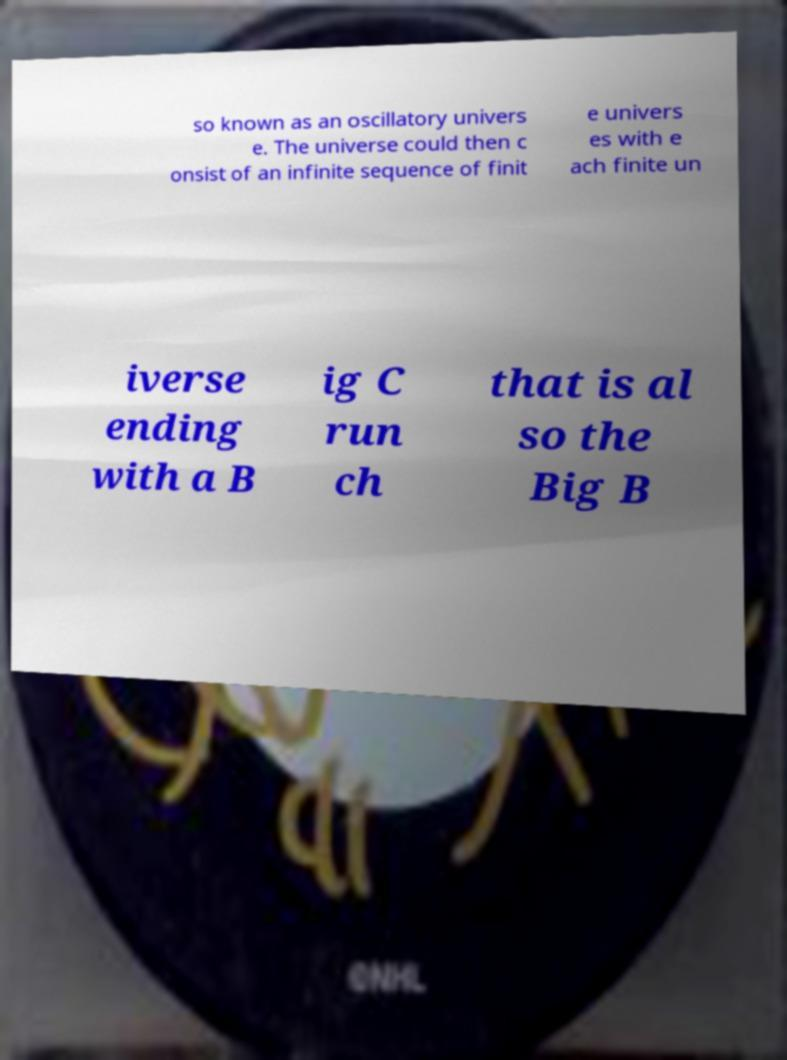Please identify and transcribe the text found in this image. so known as an oscillatory univers e. The universe could then c onsist of an infinite sequence of finit e univers es with e ach finite un iverse ending with a B ig C run ch that is al so the Big B 